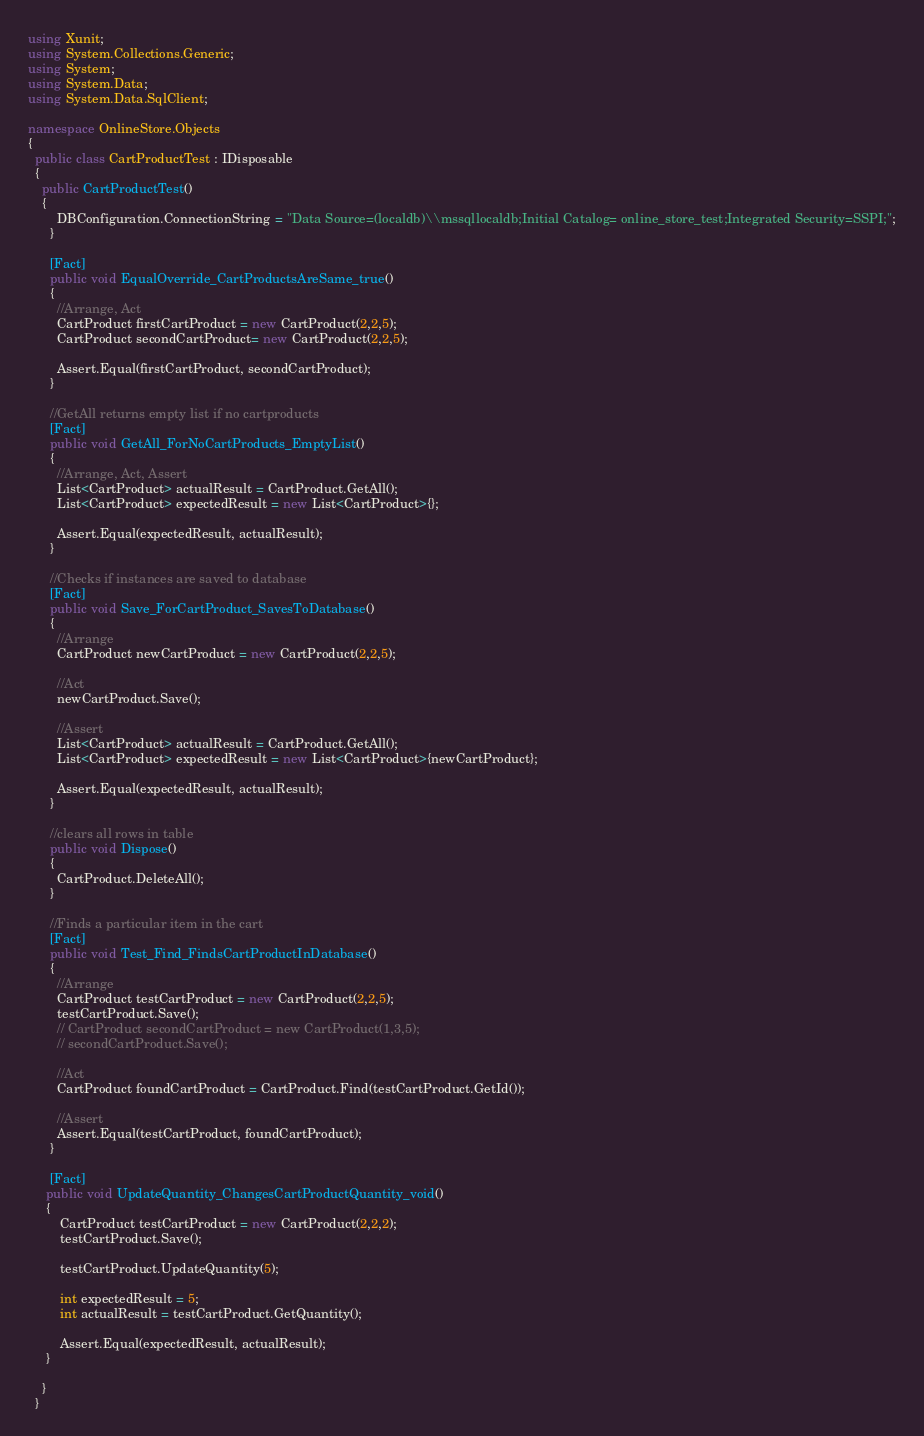Convert code to text. <code><loc_0><loc_0><loc_500><loc_500><_C#_>using Xunit;
using System.Collections.Generic;
using System;
using System.Data;
using System.Data.SqlClient;

namespace OnlineStore.Objects
{
  public class CartProductTest : IDisposable
  {
    public CartProductTest()
    {
        DBConfiguration.ConnectionString = "Data Source=(localdb)\\mssqllocaldb;Initial Catalog= online_store_test;Integrated Security=SSPI;";
      }

      [Fact]
      public void EqualOverride_CartProductsAreSame_true()
      {
        //Arrange, Act
        CartProduct firstCartProduct = new CartProduct(2,2,5);
        CartProduct secondCartProduct= new CartProduct(2,2,5);

        Assert.Equal(firstCartProduct, secondCartProduct);
      }

      //GetAll returns empty list if no cartproducts
      [Fact]
      public void GetAll_ForNoCartProducts_EmptyList()
      {
        //Arrange, Act, Assert
        List<CartProduct> actualResult = CartProduct.GetAll();
        List<CartProduct> expectedResult = new List<CartProduct>{};

        Assert.Equal(expectedResult, actualResult);
      }

      //Checks if instances are saved to database
      [Fact]
      public void Save_ForCartProduct_SavesToDatabase()
      {
        //Arrange
        CartProduct newCartProduct = new CartProduct(2,2,5);

        //Act
        newCartProduct.Save();

        //Assert
        List<CartProduct> actualResult = CartProduct.GetAll();
        List<CartProduct> expectedResult = new List<CartProduct>{newCartProduct};

        Assert.Equal(expectedResult, actualResult);
      }

      //clears all rows in table
      public void Dispose()
      {
        CartProduct.DeleteAll();
      }

      //Finds a particular item in the cart
      [Fact]
      public void Test_Find_FindsCartProductInDatabase()
      {
        //Arrange
        CartProduct testCartProduct = new CartProduct(2,2,5);
        testCartProduct.Save();
        // CartProduct secondCartProduct = new CartProduct(1,3,5);
        // secondCartProduct.Save();

        //Act
        CartProduct foundCartProduct = CartProduct.Find(testCartProduct.GetId());

        //Assert
        Assert.Equal(testCartProduct, foundCartProduct);
      }

      [Fact]
     public void UpdateQuantity_ChangesCartProductQuantity_void()
     {
         CartProduct testCartProduct = new CartProduct(2,2,2);
         testCartProduct.Save();

         testCartProduct.UpdateQuantity(5);

         int expectedResult = 5;
         int actualResult = testCartProduct.GetQuantity();

         Assert.Equal(expectedResult, actualResult);
     }

    }
  }
</code> 